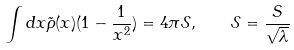<formula> <loc_0><loc_0><loc_500><loc_500>\int d x \tilde { \rho } ( x ) ( 1 - \frac { 1 } { x ^ { 2 } } ) = 4 \pi \mathcal { S } , \quad \mathcal { S } = \frac { S } { \sqrt { \lambda } }</formula> 